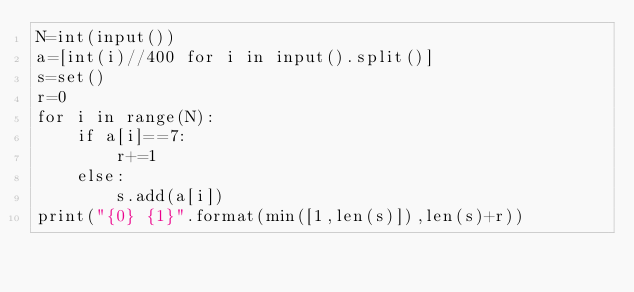Convert code to text. <code><loc_0><loc_0><loc_500><loc_500><_Python_>N=int(input())
a=[int(i)//400 for i in input().split()]
s=set()
r=0
for i in range(N):
    if a[i]==7:
        r+=1
    else:
        s.add(a[i])
print("{0} {1}".format(min([1,len(s)]),len(s)+r))
</code> 